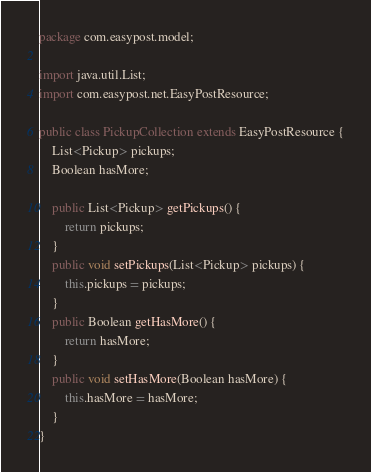Convert code to text. <code><loc_0><loc_0><loc_500><loc_500><_Java_>package com.easypost.model;

import java.util.List;
import com.easypost.net.EasyPostResource;

public class PickupCollection extends EasyPostResource {
    List<Pickup> pickups;
    Boolean hasMore;

    public List<Pickup> getPickups() {
        return pickups;
    }
    public void setPickups(List<Pickup> pickups) {
        this.pickups = pickups;
    }
    public Boolean getHasMore() {
        return hasMore;
    }
    public void setHasMore(Boolean hasMore) {
        this.hasMore = hasMore;
    }
}
</code> 